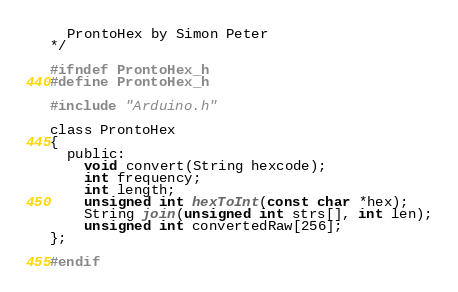<code> <loc_0><loc_0><loc_500><loc_500><_C_>  ProntoHex by Simon Peter
*/

#ifndef ProntoHex_h
#define ProntoHex_h

#include "Arduino.h"

class ProntoHex
{
  public:
    void convert(String hexcode);
    int frequency;
    int length;
    unsigned int hexToInt(const char *hex);
    String join(unsigned int strs[], int len);
    unsigned int convertedRaw[256];
};

#endif
</code> 